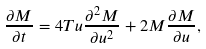<formula> <loc_0><loc_0><loc_500><loc_500>\frac { \partial M } { \partial t } = 4 T u \frac { \partial ^ { 2 } M } { \partial u ^ { 2 } } + 2 M \frac { \partial M } { \partial u } ,</formula> 